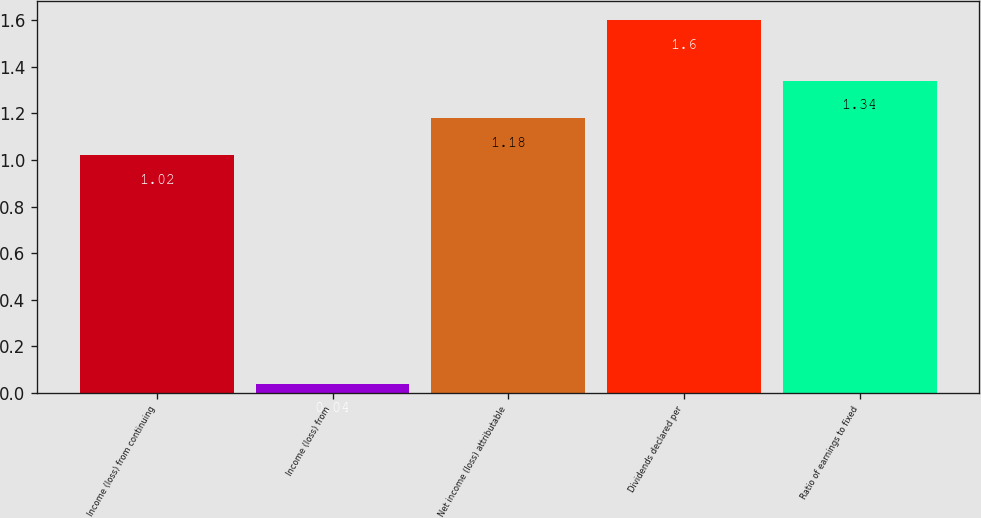Convert chart to OTSL. <chart><loc_0><loc_0><loc_500><loc_500><bar_chart><fcel>Income (loss) from continuing<fcel>Income (loss) from<fcel>Net income (loss) attributable<fcel>Dividends declared per<fcel>Ratio of earnings to fixed<nl><fcel>1.02<fcel>0.04<fcel>1.18<fcel>1.6<fcel>1.34<nl></chart> 